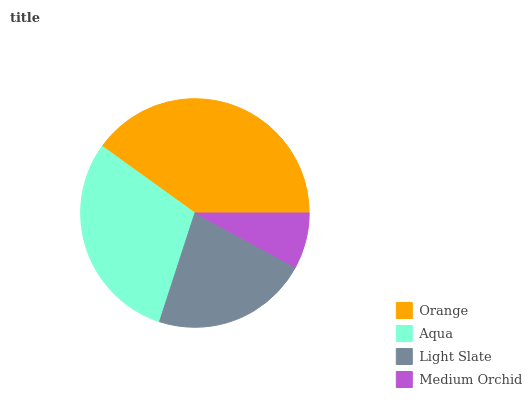Is Medium Orchid the minimum?
Answer yes or no. Yes. Is Orange the maximum?
Answer yes or no. Yes. Is Aqua the minimum?
Answer yes or no. No. Is Aqua the maximum?
Answer yes or no. No. Is Orange greater than Aqua?
Answer yes or no. Yes. Is Aqua less than Orange?
Answer yes or no. Yes. Is Aqua greater than Orange?
Answer yes or no. No. Is Orange less than Aqua?
Answer yes or no. No. Is Aqua the high median?
Answer yes or no. Yes. Is Light Slate the low median?
Answer yes or no. Yes. Is Medium Orchid the high median?
Answer yes or no. No. Is Aqua the low median?
Answer yes or no. No. 